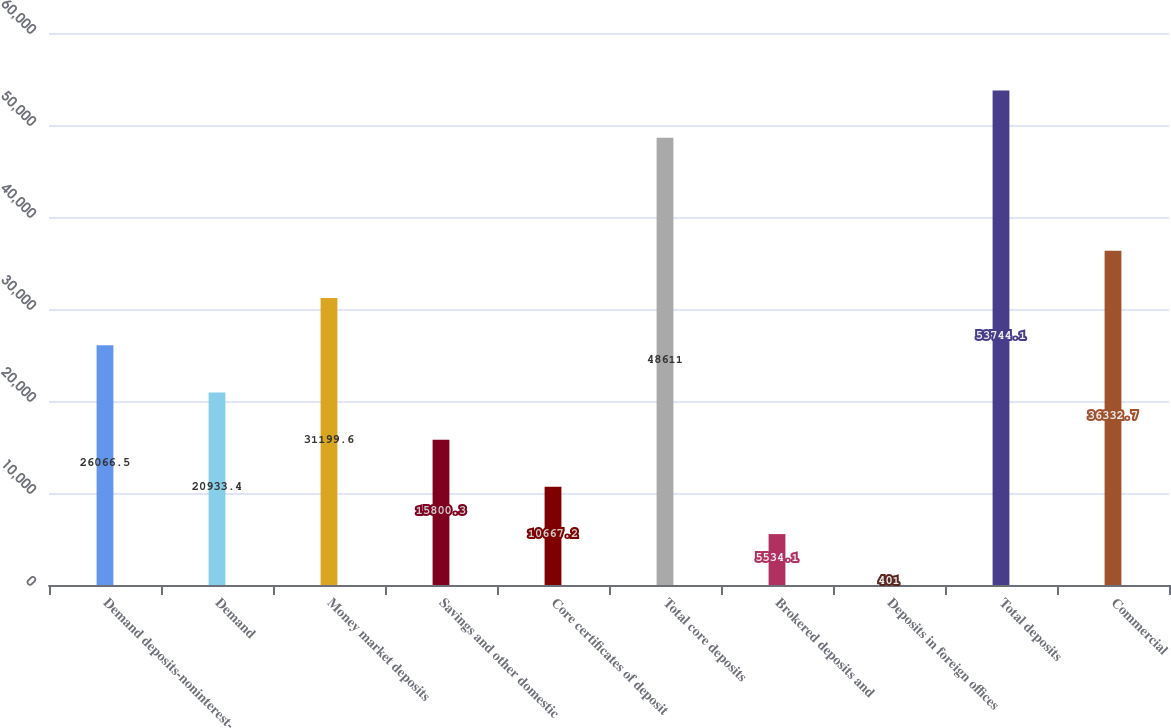<chart> <loc_0><loc_0><loc_500><loc_500><bar_chart><fcel>Demand deposits-noninterest-<fcel>Demand<fcel>Money market deposits<fcel>Savings and other domestic<fcel>Core certificates of deposit<fcel>Total core deposits<fcel>Brokered deposits and<fcel>Deposits in foreign offices<fcel>Total deposits<fcel>Commercial<nl><fcel>26066.5<fcel>20933.4<fcel>31199.6<fcel>15800.3<fcel>10667.2<fcel>48611<fcel>5534.1<fcel>401<fcel>53744.1<fcel>36332.7<nl></chart> 